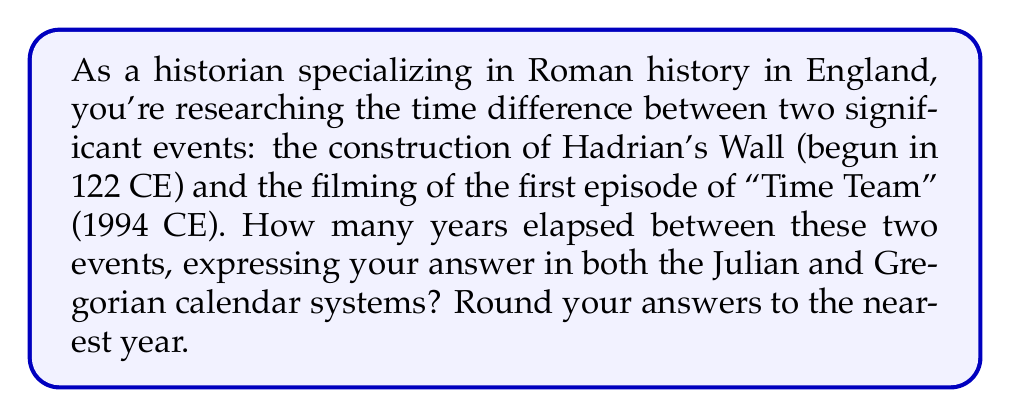Help me with this question. To solve this problem, we need to consider the difference between the Julian and Gregorian calendar systems:

1. First, let's calculate the time difference using the Common Era (CE) system:
   1994 CE - 122 CE = 1872 years

2. The Julian calendar was used until 1582 CE when the Gregorian calendar was introduced. The Gregorian calendar corrected the Julian calendar's drift by dropping 10 days in October 1582.

3. To convert from Julian to Gregorian years for dates after 1582, we need to account for the difference between the two systems. The difference grows by approximately 1 day every 128 years.

4. Time elapsed from 122 CE to 1582 CE:
   1582 - 122 = 1460 years

5. Time elapsed from 1582 CE to 1994 CE:
   1994 - 1582 = 412 years

6. Calculating the additional days in the Gregorian system:
   $$ \text{Additional days} = 10 + \left\lfloor\frac{412}{128}\right\rfloor = 10 + 3 = 13 \text{ days} $$

7. Converting 13 days to years:
   $$ \frac{13 \text{ days}}{365.25 \text{ days/year}} \approx 0.0356 \text{ years} $$

8. Adjusting the total time difference for the Gregorian calendar:
   1872 years - 0.0356 years ≈ 1871.96 years

Therefore, rounded to the nearest year:
- Julian calendar: 1872 years
- Gregorian calendar: 1872 years

The difference is less than half a year, so both systems round to the same value.
Answer: Julian calendar: 1872 years
Gregorian calendar: 1872 years 